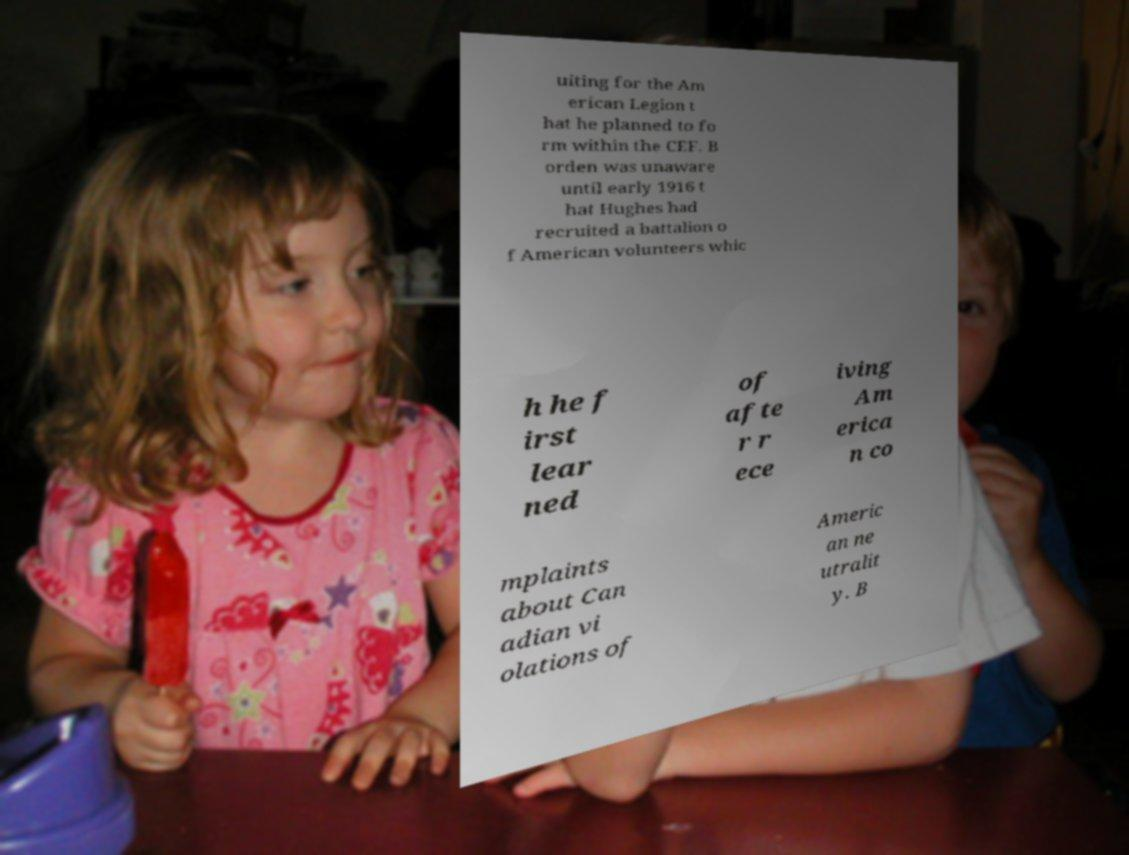Could you assist in decoding the text presented in this image and type it out clearly? uiting for the Am erican Legion t hat he planned to fo rm within the CEF. B orden was unaware until early 1916 t hat Hughes had recruited a battalion o f American volunteers whic h he f irst lear ned of afte r r ece iving Am erica n co mplaints about Can adian vi olations of Americ an ne utralit y. B 